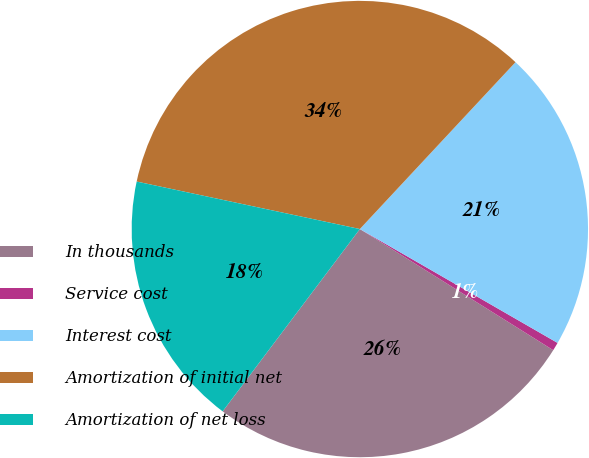Convert chart. <chart><loc_0><loc_0><loc_500><loc_500><pie_chart><fcel>In thousands<fcel>Service cost<fcel>Interest cost<fcel>Amortization of initial net<fcel>Amortization of net loss<nl><fcel>26.36%<fcel>0.59%<fcel>21.37%<fcel>33.61%<fcel>18.07%<nl></chart> 